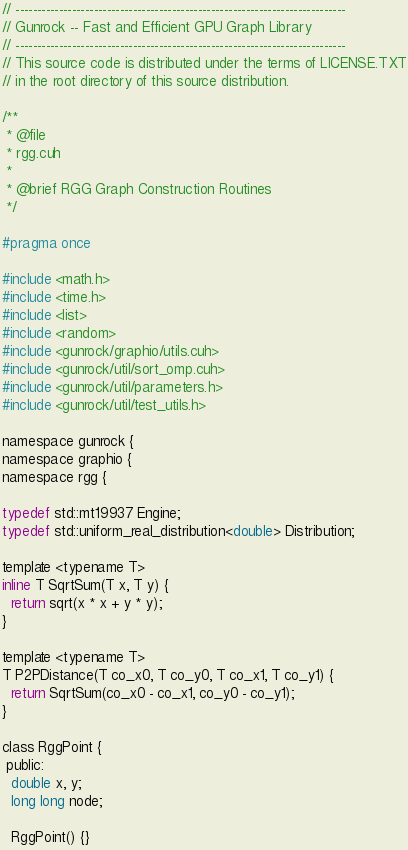Convert code to text. <code><loc_0><loc_0><loc_500><loc_500><_Cuda_>// ----------------------------------------------------------------------------
// Gunrock -- Fast and Efficient GPU Graph Library
// ----------------------------------------------------------------------------
// This source code is distributed under the terms of LICENSE.TXT
// in the root directory of this source distribution.

/**
 * @file
 * rgg.cuh
 *
 * @brief RGG Graph Construction Routines
 */

#pragma once

#include <math.h>
#include <time.h>
#include <list>
#include <random>
#include <gunrock/graphio/utils.cuh>
#include <gunrock/util/sort_omp.cuh>
#include <gunrock/util/parameters.h>
#include <gunrock/util/test_utils.h>

namespace gunrock {
namespace graphio {
namespace rgg {

typedef std::mt19937 Engine;
typedef std::uniform_real_distribution<double> Distribution;

template <typename T>
inline T SqrtSum(T x, T y) {
  return sqrt(x * x + y * y);
}

template <typename T>
T P2PDistance(T co_x0, T co_y0, T co_x1, T co_y1) {
  return SqrtSum(co_x0 - co_x1, co_y0 - co_y1);
}

class RggPoint {
 public:
  double x, y;
  long long node;

  RggPoint() {}</code> 